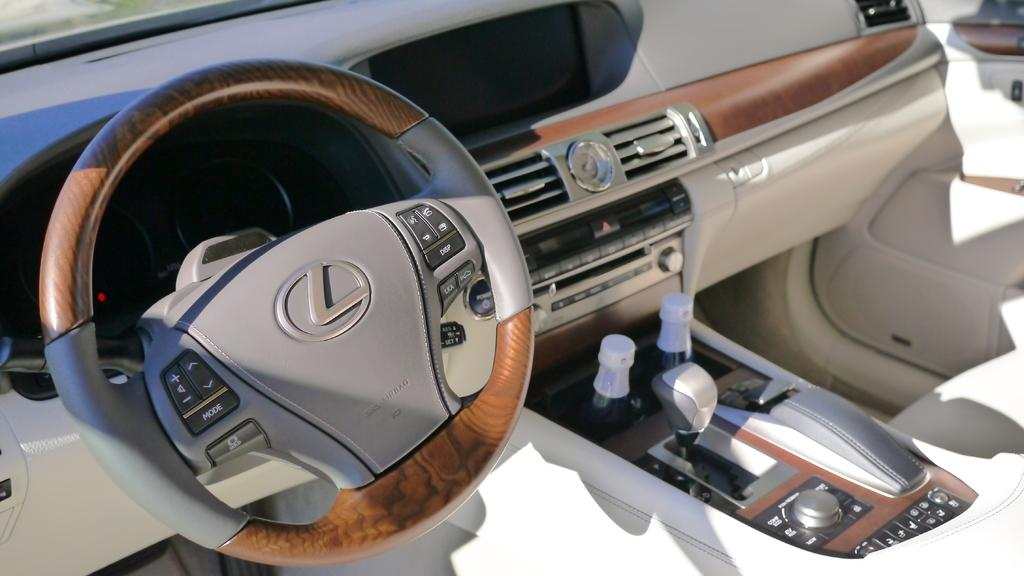What type of environment is depicted in the image? The image shows an inside view of a car. What is the main control device in the car? The steering wheel is visible in the image. What type of objects can be seen in the car? There are bottles present in the image. What type of controls might be used to operate the car's features? Buttons are visible in the image. How many trees can be seen through the car's windows in the image? There are no trees visible through the car's windows in the image. What type of animals are pulling the car in the image? There are no animals present in the image, and the car is not being pulled by any animals. 